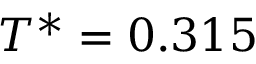Convert formula to latex. <formula><loc_0><loc_0><loc_500><loc_500>T ^ { * } = 0 . 3 1 5</formula> 